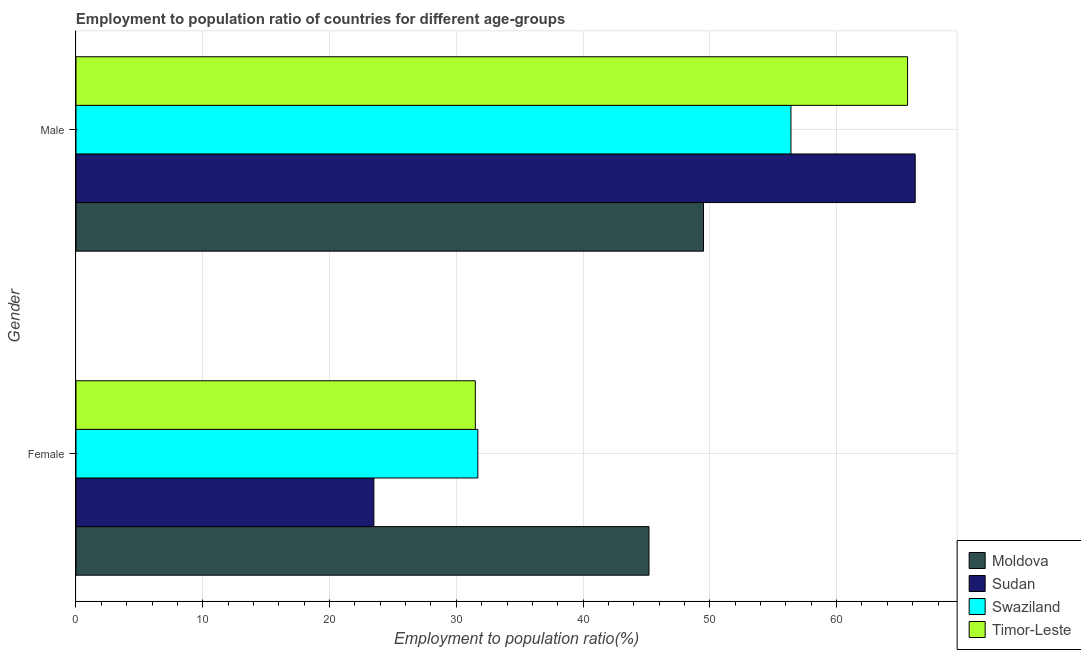How many different coloured bars are there?
Your answer should be compact. 4. Are the number of bars on each tick of the Y-axis equal?
Provide a short and direct response. Yes. What is the label of the 1st group of bars from the top?
Your response must be concise. Male. What is the employment to population ratio(male) in Moldova?
Your answer should be very brief. 49.5. Across all countries, what is the maximum employment to population ratio(female)?
Your answer should be very brief. 45.2. Across all countries, what is the minimum employment to population ratio(male)?
Offer a terse response. 49.5. In which country was the employment to population ratio(male) maximum?
Your answer should be very brief. Sudan. In which country was the employment to population ratio(male) minimum?
Make the answer very short. Moldova. What is the total employment to population ratio(male) in the graph?
Ensure brevity in your answer.  237.7. What is the difference between the employment to population ratio(male) in Moldova and that in Sudan?
Your answer should be very brief. -16.7. What is the difference between the employment to population ratio(female) in Timor-Leste and the employment to population ratio(male) in Swaziland?
Make the answer very short. -24.9. What is the average employment to population ratio(female) per country?
Your response must be concise. 32.98. What is the difference between the employment to population ratio(male) and employment to population ratio(female) in Timor-Leste?
Your answer should be very brief. 34.1. In how many countries, is the employment to population ratio(female) greater than 30 %?
Your response must be concise. 3. What is the ratio of the employment to population ratio(female) in Timor-Leste to that in Swaziland?
Your answer should be compact. 0.99. Is the employment to population ratio(female) in Sudan less than that in Swaziland?
Your response must be concise. Yes. What does the 1st bar from the top in Female represents?
Your answer should be very brief. Timor-Leste. What does the 3rd bar from the bottom in Female represents?
Ensure brevity in your answer.  Swaziland. Are all the bars in the graph horizontal?
Provide a succinct answer. Yes. How many countries are there in the graph?
Keep it short and to the point. 4. Are the values on the major ticks of X-axis written in scientific E-notation?
Keep it short and to the point. No. Does the graph contain any zero values?
Offer a very short reply. No. Does the graph contain grids?
Make the answer very short. Yes. Where does the legend appear in the graph?
Provide a succinct answer. Bottom right. How many legend labels are there?
Ensure brevity in your answer.  4. How are the legend labels stacked?
Give a very brief answer. Vertical. What is the title of the graph?
Keep it short and to the point. Employment to population ratio of countries for different age-groups. Does "Fragile and conflict affected situations" appear as one of the legend labels in the graph?
Your response must be concise. No. What is the label or title of the X-axis?
Your answer should be compact. Employment to population ratio(%). What is the label or title of the Y-axis?
Make the answer very short. Gender. What is the Employment to population ratio(%) in Moldova in Female?
Offer a very short reply. 45.2. What is the Employment to population ratio(%) of Swaziland in Female?
Your answer should be very brief. 31.7. What is the Employment to population ratio(%) in Timor-Leste in Female?
Your answer should be very brief. 31.5. What is the Employment to population ratio(%) of Moldova in Male?
Provide a short and direct response. 49.5. What is the Employment to population ratio(%) of Sudan in Male?
Offer a very short reply. 66.2. What is the Employment to population ratio(%) in Swaziland in Male?
Provide a short and direct response. 56.4. What is the Employment to population ratio(%) of Timor-Leste in Male?
Your answer should be very brief. 65.6. Across all Gender, what is the maximum Employment to population ratio(%) in Moldova?
Keep it short and to the point. 49.5. Across all Gender, what is the maximum Employment to population ratio(%) in Sudan?
Provide a succinct answer. 66.2. Across all Gender, what is the maximum Employment to population ratio(%) of Swaziland?
Keep it short and to the point. 56.4. Across all Gender, what is the maximum Employment to population ratio(%) in Timor-Leste?
Ensure brevity in your answer.  65.6. Across all Gender, what is the minimum Employment to population ratio(%) of Moldova?
Make the answer very short. 45.2. Across all Gender, what is the minimum Employment to population ratio(%) in Sudan?
Your answer should be very brief. 23.5. Across all Gender, what is the minimum Employment to population ratio(%) in Swaziland?
Provide a succinct answer. 31.7. Across all Gender, what is the minimum Employment to population ratio(%) of Timor-Leste?
Provide a succinct answer. 31.5. What is the total Employment to population ratio(%) in Moldova in the graph?
Make the answer very short. 94.7. What is the total Employment to population ratio(%) in Sudan in the graph?
Offer a very short reply. 89.7. What is the total Employment to population ratio(%) in Swaziland in the graph?
Offer a terse response. 88.1. What is the total Employment to population ratio(%) of Timor-Leste in the graph?
Make the answer very short. 97.1. What is the difference between the Employment to population ratio(%) of Sudan in Female and that in Male?
Offer a very short reply. -42.7. What is the difference between the Employment to population ratio(%) of Swaziland in Female and that in Male?
Offer a terse response. -24.7. What is the difference between the Employment to population ratio(%) of Timor-Leste in Female and that in Male?
Provide a succinct answer. -34.1. What is the difference between the Employment to population ratio(%) of Moldova in Female and the Employment to population ratio(%) of Sudan in Male?
Give a very brief answer. -21. What is the difference between the Employment to population ratio(%) of Moldova in Female and the Employment to population ratio(%) of Swaziland in Male?
Your answer should be very brief. -11.2. What is the difference between the Employment to population ratio(%) of Moldova in Female and the Employment to population ratio(%) of Timor-Leste in Male?
Keep it short and to the point. -20.4. What is the difference between the Employment to population ratio(%) of Sudan in Female and the Employment to population ratio(%) of Swaziland in Male?
Offer a terse response. -32.9. What is the difference between the Employment to population ratio(%) of Sudan in Female and the Employment to population ratio(%) of Timor-Leste in Male?
Your answer should be compact. -42.1. What is the difference between the Employment to population ratio(%) of Swaziland in Female and the Employment to population ratio(%) of Timor-Leste in Male?
Your answer should be very brief. -33.9. What is the average Employment to population ratio(%) in Moldova per Gender?
Your answer should be very brief. 47.35. What is the average Employment to population ratio(%) in Sudan per Gender?
Your answer should be compact. 44.85. What is the average Employment to population ratio(%) of Swaziland per Gender?
Provide a succinct answer. 44.05. What is the average Employment to population ratio(%) of Timor-Leste per Gender?
Your answer should be very brief. 48.55. What is the difference between the Employment to population ratio(%) of Moldova and Employment to population ratio(%) of Sudan in Female?
Keep it short and to the point. 21.7. What is the difference between the Employment to population ratio(%) of Moldova and Employment to population ratio(%) of Swaziland in Female?
Your response must be concise. 13.5. What is the difference between the Employment to population ratio(%) in Sudan and Employment to population ratio(%) in Swaziland in Female?
Give a very brief answer. -8.2. What is the difference between the Employment to population ratio(%) of Moldova and Employment to population ratio(%) of Sudan in Male?
Provide a succinct answer. -16.7. What is the difference between the Employment to population ratio(%) of Moldova and Employment to population ratio(%) of Swaziland in Male?
Keep it short and to the point. -6.9. What is the difference between the Employment to population ratio(%) of Moldova and Employment to population ratio(%) of Timor-Leste in Male?
Your response must be concise. -16.1. What is the difference between the Employment to population ratio(%) in Sudan and Employment to population ratio(%) in Swaziland in Male?
Provide a short and direct response. 9.8. What is the difference between the Employment to population ratio(%) of Sudan and Employment to population ratio(%) of Timor-Leste in Male?
Offer a very short reply. 0.6. What is the ratio of the Employment to population ratio(%) in Moldova in Female to that in Male?
Your answer should be compact. 0.91. What is the ratio of the Employment to population ratio(%) of Sudan in Female to that in Male?
Ensure brevity in your answer.  0.35. What is the ratio of the Employment to population ratio(%) in Swaziland in Female to that in Male?
Make the answer very short. 0.56. What is the ratio of the Employment to population ratio(%) of Timor-Leste in Female to that in Male?
Offer a terse response. 0.48. What is the difference between the highest and the second highest Employment to population ratio(%) in Moldova?
Your answer should be very brief. 4.3. What is the difference between the highest and the second highest Employment to population ratio(%) of Sudan?
Ensure brevity in your answer.  42.7. What is the difference between the highest and the second highest Employment to population ratio(%) in Swaziland?
Provide a short and direct response. 24.7. What is the difference between the highest and the second highest Employment to population ratio(%) of Timor-Leste?
Give a very brief answer. 34.1. What is the difference between the highest and the lowest Employment to population ratio(%) in Moldova?
Give a very brief answer. 4.3. What is the difference between the highest and the lowest Employment to population ratio(%) in Sudan?
Offer a very short reply. 42.7. What is the difference between the highest and the lowest Employment to population ratio(%) in Swaziland?
Keep it short and to the point. 24.7. What is the difference between the highest and the lowest Employment to population ratio(%) in Timor-Leste?
Your response must be concise. 34.1. 